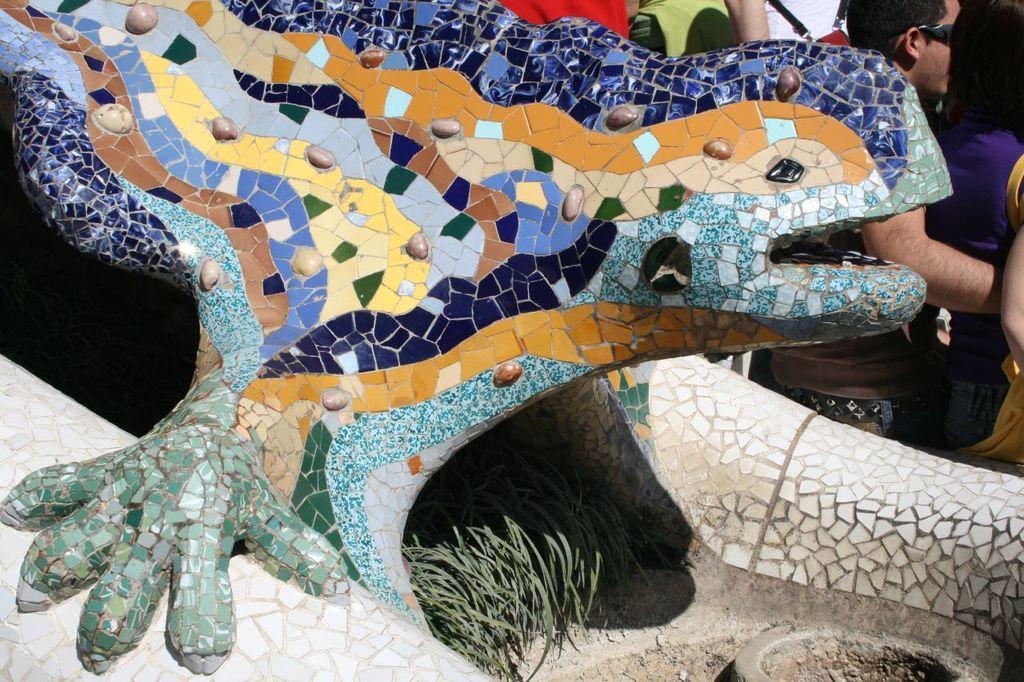Describe this image in one or two sentences. Here I can see a sculpture which is looking like an animal. On this I can see multiple color marbles. On the right top of the image I can see few people are standing. 